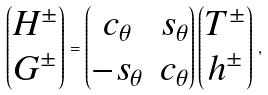Convert formula to latex. <formula><loc_0><loc_0><loc_500><loc_500>\begin{pmatrix} H ^ { \pm } \\ G ^ { \pm } \end{pmatrix} = \begin{pmatrix} c _ { \theta } & s _ { \theta } \\ - s _ { \theta } & c _ { \theta } \end{pmatrix} \begin{pmatrix} T ^ { \pm } \\ h ^ { \pm } \end{pmatrix} \, ,</formula> 